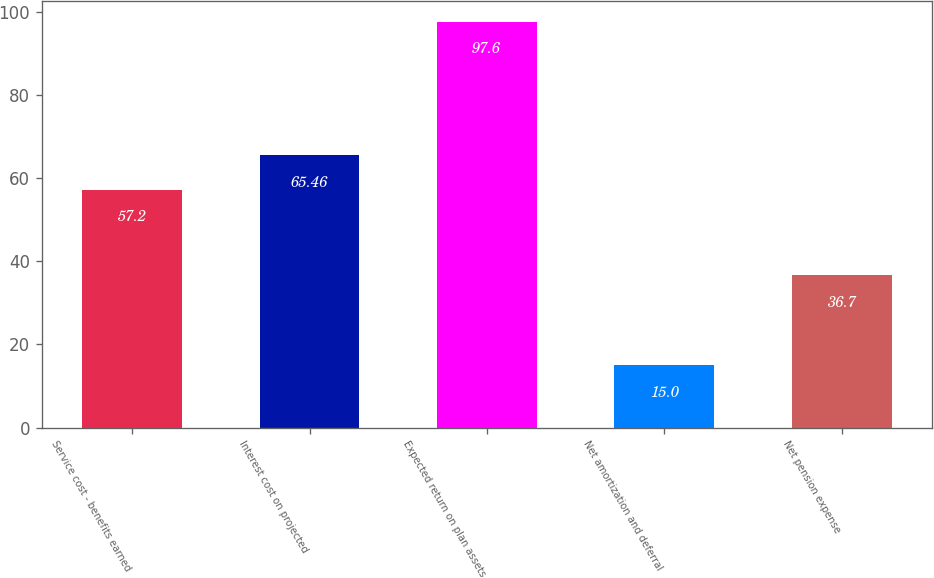<chart> <loc_0><loc_0><loc_500><loc_500><bar_chart><fcel>Service cost - benefits earned<fcel>Interest cost on projected<fcel>Expected return on plan assets<fcel>Net amortization and deferral<fcel>Net pension expense<nl><fcel>57.2<fcel>65.46<fcel>97.6<fcel>15<fcel>36.7<nl></chart> 